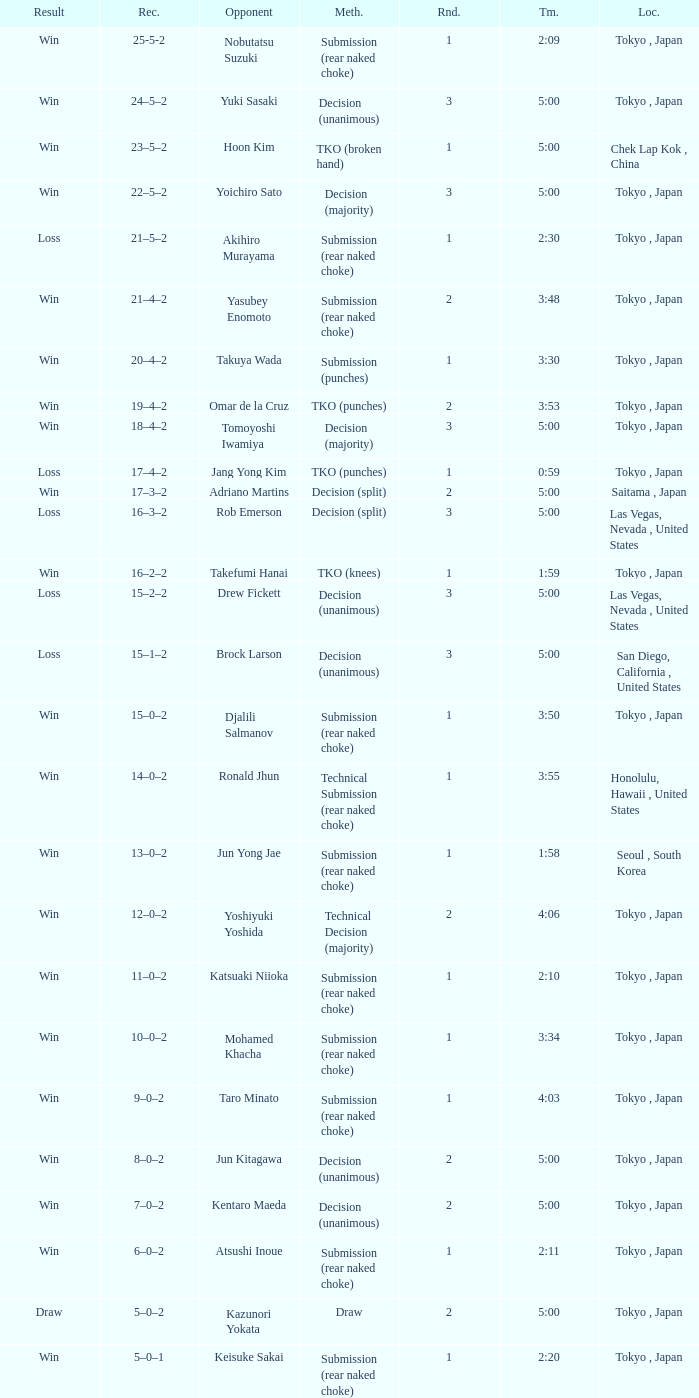What is the total number of rounds when Drew Fickett was the opponent and the time is 5:00? 1.0. Could you help me parse every detail presented in this table? {'header': ['Result', 'Rec.', 'Opponent', 'Meth.', 'Rnd.', 'Tm.', 'Loc.'], 'rows': [['Win', '25-5-2', 'Nobutatsu Suzuki', 'Submission (rear naked choke)', '1', '2:09', 'Tokyo , Japan'], ['Win', '24–5–2', 'Yuki Sasaki', 'Decision (unanimous)', '3', '5:00', 'Tokyo , Japan'], ['Win', '23–5–2', 'Hoon Kim', 'TKO (broken hand)', '1', '5:00', 'Chek Lap Kok , China'], ['Win', '22–5–2', 'Yoichiro Sato', 'Decision (majority)', '3', '5:00', 'Tokyo , Japan'], ['Loss', '21–5–2', 'Akihiro Murayama', 'Submission (rear naked choke)', '1', '2:30', 'Tokyo , Japan'], ['Win', '21–4–2', 'Yasubey Enomoto', 'Submission (rear naked choke)', '2', '3:48', 'Tokyo , Japan'], ['Win', '20–4–2', 'Takuya Wada', 'Submission (punches)', '1', '3:30', 'Tokyo , Japan'], ['Win', '19–4–2', 'Omar de la Cruz', 'TKO (punches)', '2', '3:53', 'Tokyo , Japan'], ['Win', '18–4–2', 'Tomoyoshi Iwamiya', 'Decision (majority)', '3', '5:00', 'Tokyo , Japan'], ['Loss', '17–4–2', 'Jang Yong Kim', 'TKO (punches)', '1', '0:59', 'Tokyo , Japan'], ['Win', '17–3–2', 'Adriano Martins', 'Decision (split)', '2', '5:00', 'Saitama , Japan'], ['Loss', '16–3–2', 'Rob Emerson', 'Decision (split)', '3', '5:00', 'Las Vegas, Nevada , United States'], ['Win', '16–2–2', 'Takefumi Hanai', 'TKO (knees)', '1', '1:59', 'Tokyo , Japan'], ['Loss', '15–2–2', 'Drew Fickett', 'Decision (unanimous)', '3', '5:00', 'Las Vegas, Nevada , United States'], ['Loss', '15–1–2', 'Brock Larson', 'Decision (unanimous)', '3', '5:00', 'San Diego, California , United States'], ['Win', '15–0–2', 'Djalili Salmanov', 'Submission (rear naked choke)', '1', '3:50', 'Tokyo , Japan'], ['Win', '14–0–2', 'Ronald Jhun', 'Technical Submission (rear naked choke)', '1', '3:55', 'Honolulu, Hawaii , United States'], ['Win', '13–0–2', 'Jun Yong Jae', 'Submission (rear naked choke)', '1', '1:58', 'Seoul , South Korea'], ['Win', '12–0–2', 'Yoshiyuki Yoshida', 'Technical Decision (majority)', '2', '4:06', 'Tokyo , Japan'], ['Win', '11–0–2', 'Katsuaki Niioka', 'Submission (rear naked choke)', '1', '2:10', 'Tokyo , Japan'], ['Win', '10–0–2', 'Mohamed Khacha', 'Submission (rear naked choke)', '1', '3:34', 'Tokyo , Japan'], ['Win', '9–0–2', 'Taro Minato', 'Submission (rear naked choke)', '1', '4:03', 'Tokyo , Japan'], ['Win', '8–0–2', 'Jun Kitagawa', 'Decision (unanimous)', '2', '5:00', 'Tokyo , Japan'], ['Win', '7–0–2', 'Kentaro Maeda', 'Decision (unanimous)', '2', '5:00', 'Tokyo , Japan'], ['Win', '6–0–2', 'Atsushi Inoue', 'Submission (rear naked choke)', '1', '2:11', 'Tokyo , Japan'], ['Draw', '5–0–2', 'Kazunori Yokata', 'Draw', '2', '5:00', 'Tokyo , Japan'], ['Win', '5–0–1', 'Keisuke Sakai', 'Submission (rear naked choke)', '1', '2:20', 'Tokyo , Japan'], ['Win', '4–0–1', 'Ichiro Kanai', 'Decision (unanimous)', '2', '5:00', 'Tokyo , Japan'], ['Win', '3–0–1', 'Daisuke Nakamura', 'Decision (unanimous)', '2', '5:00', 'Tokyo , Japan'], ['Draw', '2–0–1', 'Ichiro Kanai', 'Draw', '2', '5:00', 'Tokyo , Japan'], ['Win', '2–0', 'Kenta Omori', 'Submission (triangle choke)', '1', '7:44', 'Tokyo , Japan'], ['Win', '1–0', 'Tomohito Tanizaki', 'TKO (punches)', '1', '0:33', 'Tokyo , Japan']]} 